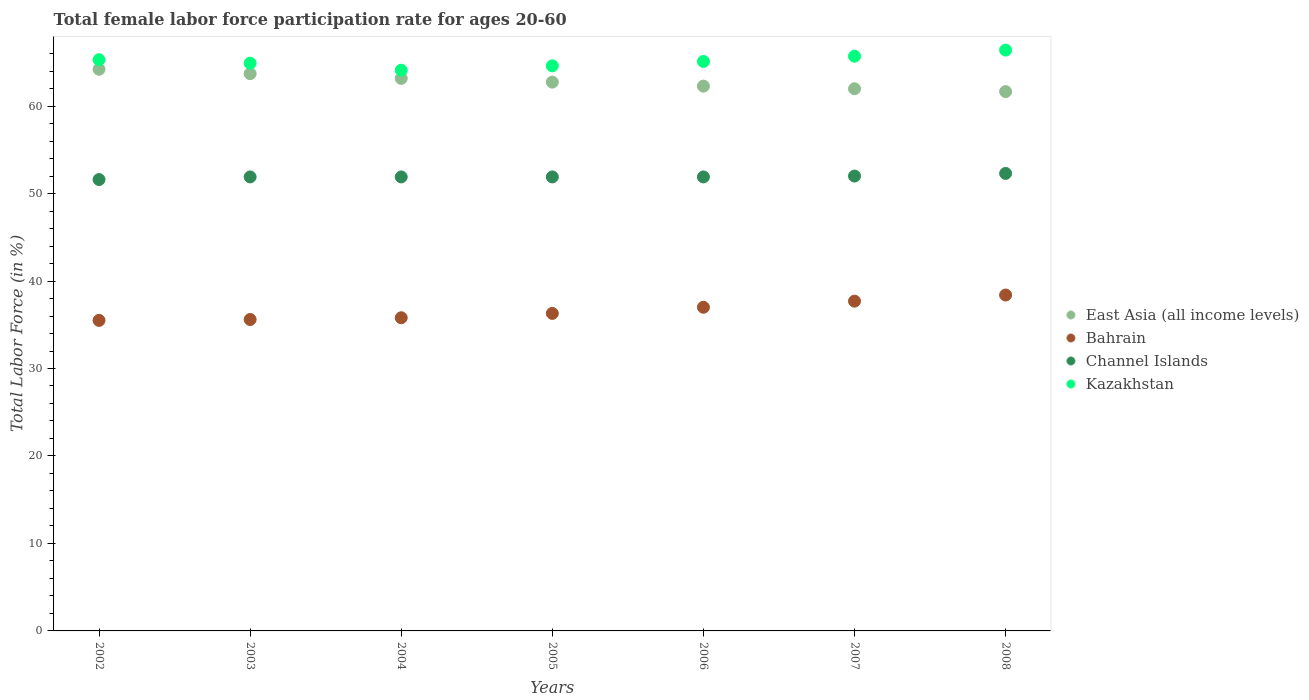How many different coloured dotlines are there?
Your response must be concise. 4. What is the female labor force participation rate in Kazakhstan in 2003?
Provide a succinct answer. 64.9. Across all years, what is the maximum female labor force participation rate in East Asia (all income levels)?
Provide a short and direct response. 64.21. Across all years, what is the minimum female labor force participation rate in Channel Islands?
Provide a short and direct response. 51.6. What is the total female labor force participation rate in Channel Islands in the graph?
Make the answer very short. 363.5. What is the difference between the female labor force participation rate in Channel Islands in 2002 and that in 2007?
Provide a short and direct response. -0.4. What is the difference between the female labor force participation rate in Bahrain in 2006 and the female labor force participation rate in Kazakhstan in 2008?
Ensure brevity in your answer.  -29.4. What is the average female labor force participation rate in Bahrain per year?
Offer a terse response. 36.61. In the year 2002, what is the difference between the female labor force participation rate in East Asia (all income levels) and female labor force participation rate in Channel Islands?
Provide a short and direct response. 12.61. In how many years, is the female labor force participation rate in East Asia (all income levels) greater than 16 %?
Make the answer very short. 7. Is the female labor force participation rate in Kazakhstan in 2002 less than that in 2007?
Your answer should be compact. Yes. Is the difference between the female labor force participation rate in East Asia (all income levels) in 2002 and 2006 greater than the difference between the female labor force participation rate in Channel Islands in 2002 and 2006?
Your answer should be compact. Yes. What is the difference between the highest and the second highest female labor force participation rate in Channel Islands?
Offer a terse response. 0.3. What is the difference between the highest and the lowest female labor force participation rate in Kazakhstan?
Offer a terse response. 2.3. Is it the case that in every year, the sum of the female labor force participation rate in East Asia (all income levels) and female labor force participation rate in Bahrain  is greater than the sum of female labor force participation rate in Kazakhstan and female labor force participation rate in Channel Islands?
Offer a terse response. No. Is the female labor force participation rate in East Asia (all income levels) strictly less than the female labor force participation rate in Kazakhstan over the years?
Keep it short and to the point. Yes. How many years are there in the graph?
Provide a succinct answer. 7. Are the values on the major ticks of Y-axis written in scientific E-notation?
Keep it short and to the point. No. Does the graph contain any zero values?
Provide a short and direct response. No. How many legend labels are there?
Offer a very short reply. 4. How are the legend labels stacked?
Offer a terse response. Vertical. What is the title of the graph?
Give a very brief answer. Total female labor force participation rate for ages 20-60. What is the label or title of the X-axis?
Give a very brief answer. Years. What is the label or title of the Y-axis?
Provide a succinct answer. Total Labor Force (in %). What is the Total Labor Force (in %) of East Asia (all income levels) in 2002?
Offer a very short reply. 64.21. What is the Total Labor Force (in %) of Bahrain in 2002?
Make the answer very short. 35.5. What is the Total Labor Force (in %) in Channel Islands in 2002?
Keep it short and to the point. 51.6. What is the Total Labor Force (in %) of Kazakhstan in 2002?
Give a very brief answer. 65.3. What is the Total Labor Force (in %) of East Asia (all income levels) in 2003?
Provide a succinct answer. 63.71. What is the Total Labor Force (in %) of Bahrain in 2003?
Give a very brief answer. 35.6. What is the Total Labor Force (in %) of Channel Islands in 2003?
Provide a succinct answer. 51.9. What is the Total Labor Force (in %) of Kazakhstan in 2003?
Make the answer very short. 64.9. What is the Total Labor Force (in %) in East Asia (all income levels) in 2004?
Your response must be concise. 63.16. What is the Total Labor Force (in %) of Bahrain in 2004?
Provide a succinct answer. 35.8. What is the Total Labor Force (in %) of Channel Islands in 2004?
Your answer should be compact. 51.9. What is the Total Labor Force (in %) of Kazakhstan in 2004?
Your response must be concise. 64.1. What is the Total Labor Force (in %) of East Asia (all income levels) in 2005?
Your answer should be compact. 62.74. What is the Total Labor Force (in %) of Bahrain in 2005?
Offer a terse response. 36.3. What is the Total Labor Force (in %) in Channel Islands in 2005?
Your response must be concise. 51.9. What is the Total Labor Force (in %) in Kazakhstan in 2005?
Ensure brevity in your answer.  64.6. What is the Total Labor Force (in %) in East Asia (all income levels) in 2006?
Your response must be concise. 62.28. What is the Total Labor Force (in %) of Channel Islands in 2006?
Offer a terse response. 51.9. What is the Total Labor Force (in %) of Kazakhstan in 2006?
Keep it short and to the point. 65.1. What is the Total Labor Force (in %) of East Asia (all income levels) in 2007?
Provide a succinct answer. 61.98. What is the Total Labor Force (in %) of Bahrain in 2007?
Offer a terse response. 37.7. What is the Total Labor Force (in %) of Channel Islands in 2007?
Ensure brevity in your answer.  52. What is the Total Labor Force (in %) in Kazakhstan in 2007?
Give a very brief answer. 65.7. What is the Total Labor Force (in %) of East Asia (all income levels) in 2008?
Keep it short and to the point. 61.66. What is the Total Labor Force (in %) of Bahrain in 2008?
Your response must be concise. 38.4. What is the Total Labor Force (in %) in Channel Islands in 2008?
Your answer should be very brief. 52.3. What is the Total Labor Force (in %) in Kazakhstan in 2008?
Provide a succinct answer. 66.4. Across all years, what is the maximum Total Labor Force (in %) of East Asia (all income levels)?
Give a very brief answer. 64.21. Across all years, what is the maximum Total Labor Force (in %) of Bahrain?
Provide a short and direct response. 38.4. Across all years, what is the maximum Total Labor Force (in %) of Channel Islands?
Your answer should be very brief. 52.3. Across all years, what is the maximum Total Labor Force (in %) of Kazakhstan?
Your response must be concise. 66.4. Across all years, what is the minimum Total Labor Force (in %) of East Asia (all income levels)?
Ensure brevity in your answer.  61.66. Across all years, what is the minimum Total Labor Force (in %) of Bahrain?
Keep it short and to the point. 35.5. Across all years, what is the minimum Total Labor Force (in %) of Channel Islands?
Your answer should be very brief. 51.6. Across all years, what is the minimum Total Labor Force (in %) of Kazakhstan?
Keep it short and to the point. 64.1. What is the total Total Labor Force (in %) of East Asia (all income levels) in the graph?
Give a very brief answer. 439.73. What is the total Total Labor Force (in %) of Bahrain in the graph?
Offer a very short reply. 256.3. What is the total Total Labor Force (in %) in Channel Islands in the graph?
Your answer should be compact. 363.5. What is the total Total Labor Force (in %) of Kazakhstan in the graph?
Your response must be concise. 456.1. What is the difference between the Total Labor Force (in %) in East Asia (all income levels) in 2002 and that in 2003?
Your response must be concise. 0.5. What is the difference between the Total Labor Force (in %) in Kazakhstan in 2002 and that in 2003?
Keep it short and to the point. 0.4. What is the difference between the Total Labor Force (in %) in East Asia (all income levels) in 2002 and that in 2004?
Your answer should be very brief. 1.04. What is the difference between the Total Labor Force (in %) in Kazakhstan in 2002 and that in 2004?
Offer a very short reply. 1.2. What is the difference between the Total Labor Force (in %) of East Asia (all income levels) in 2002 and that in 2005?
Provide a succinct answer. 1.47. What is the difference between the Total Labor Force (in %) in Bahrain in 2002 and that in 2005?
Your response must be concise. -0.8. What is the difference between the Total Labor Force (in %) of Kazakhstan in 2002 and that in 2005?
Provide a succinct answer. 0.7. What is the difference between the Total Labor Force (in %) in East Asia (all income levels) in 2002 and that in 2006?
Ensure brevity in your answer.  1.93. What is the difference between the Total Labor Force (in %) in Channel Islands in 2002 and that in 2006?
Keep it short and to the point. -0.3. What is the difference between the Total Labor Force (in %) of East Asia (all income levels) in 2002 and that in 2007?
Offer a very short reply. 2.23. What is the difference between the Total Labor Force (in %) in Bahrain in 2002 and that in 2007?
Give a very brief answer. -2.2. What is the difference between the Total Labor Force (in %) in Channel Islands in 2002 and that in 2007?
Keep it short and to the point. -0.4. What is the difference between the Total Labor Force (in %) in East Asia (all income levels) in 2002 and that in 2008?
Your answer should be compact. 2.55. What is the difference between the Total Labor Force (in %) of Bahrain in 2002 and that in 2008?
Offer a very short reply. -2.9. What is the difference between the Total Labor Force (in %) of Kazakhstan in 2002 and that in 2008?
Your answer should be very brief. -1.1. What is the difference between the Total Labor Force (in %) of East Asia (all income levels) in 2003 and that in 2004?
Make the answer very short. 0.54. What is the difference between the Total Labor Force (in %) in Channel Islands in 2003 and that in 2004?
Ensure brevity in your answer.  0. What is the difference between the Total Labor Force (in %) of Channel Islands in 2003 and that in 2005?
Keep it short and to the point. 0. What is the difference between the Total Labor Force (in %) in East Asia (all income levels) in 2003 and that in 2006?
Make the answer very short. 1.43. What is the difference between the Total Labor Force (in %) in Bahrain in 2003 and that in 2006?
Offer a very short reply. -1.4. What is the difference between the Total Labor Force (in %) in Kazakhstan in 2003 and that in 2006?
Your response must be concise. -0.2. What is the difference between the Total Labor Force (in %) of East Asia (all income levels) in 2003 and that in 2007?
Give a very brief answer. 1.73. What is the difference between the Total Labor Force (in %) of Kazakhstan in 2003 and that in 2007?
Your answer should be compact. -0.8. What is the difference between the Total Labor Force (in %) of East Asia (all income levels) in 2003 and that in 2008?
Provide a succinct answer. 2.05. What is the difference between the Total Labor Force (in %) of Bahrain in 2003 and that in 2008?
Your answer should be very brief. -2.8. What is the difference between the Total Labor Force (in %) of Channel Islands in 2003 and that in 2008?
Keep it short and to the point. -0.4. What is the difference between the Total Labor Force (in %) in East Asia (all income levels) in 2004 and that in 2005?
Make the answer very short. 0.42. What is the difference between the Total Labor Force (in %) of East Asia (all income levels) in 2004 and that in 2006?
Give a very brief answer. 0.88. What is the difference between the Total Labor Force (in %) of Kazakhstan in 2004 and that in 2006?
Offer a very short reply. -1. What is the difference between the Total Labor Force (in %) of East Asia (all income levels) in 2004 and that in 2007?
Your response must be concise. 1.18. What is the difference between the Total Labor Force (in %) of Channel Islands in 2004 and that in 2007?
Your answer should be very brief. -0.1. What is the difference between the Total Labor Force (in %) in Kazakhstan in 2004 and that in 2007?
Your answer should be compact. -1.6. What is the difference between the Total Labor Force (in %) of East Asia (all income levels) in 2004 and that in 2008?
Your response must be concise. 1.51. What is the difference between the Total Labor Force (in %) of East Asia (all income levels) in 2005 and that in 2006?
Your answer should be compact. 0.46. What is the difference between the Total Labor Force (in %) in Bahrain in 2005 and that in 2006?
Your answer should be compact. -0.7. What is the difference between the Total Labor Force (in %) in Channel Islands in 2005 and that in 2006?
Your answer should be very brief. 0. What is the difference between the Total Labor Force (in %) of Kazakhstan in 2005 and that in 2006?
Provide a short and direct response. -0.5. What is the difference between the Total Labor Force (in %) of East Asia (all income levels) in 2005 and that in 2007?
Your answer should be very brief. 0.76. What is the difference between the Total Labor Force (in %) in Channel Islands in 2005 and that in 2007?
Your response must be concise. -0.1. What is the difference between the Total Labor Force (in %) in East Asia (all income levels) in 2005 and that in 2008?
Give a very brief answer. 1.08. What is the difference between the Total Labor Force (in %) of Bahrain in 2005 and that in 2008?
Provide a short and direct response. -2.1. What is the difference between the Total Labor Force (in %) of Channel Islands in 2005 and that in 2008?
Give a very brief answer. -0.4. What is the difference between the Total Labor Force (in %) of Kazakhstan in 2005 and that in 2008?
Offer a very short reply. -1.8. What is the difference between the Total Labor Force (in %) in East Asia (all income levels) in 2006 and that in 2007?
Your answer should be compact. 0.3. What is the difference between the Total Labor Force (in %) in Channel Islands in 2006 and that in 2007?
Offer a terse response. -0.1. What is the difference between the Total Labor Force (in %) of East Asia (all income levels) in 2006 and that in 2008?
Your answer should be compact. 0.62. What is the difference between the Total Labor Force (in %) of Bahrain in 2006 and that in 2008?
Your answer should be compact. -1.4. What is the difference between the Total Labor Force (in %) of Kazakhstan in 2006 and that in 2008?
Keep it short and to the point. -1.3. What is the difference between the Total Labor Force (in %) in East Asia (all income levels) in 2007 and that in 2008?
Offer a very short reply. 0.33. What is the difference between the Total Labor Force (in %) in Channel Islands in 2007 and that in 2008?
Make the answer very short. -0.3. What is the difference between the Total Labor Force (in %) of East Asia (all income levels) in 2002 and the Total Labor Force (in %) of Bahrain in 2003?
Your response must be concise. 28.61. What is the difference between the Total Labor Force (in %) of East Asia (all income levels) in 2002 and the Total Labor Force (in %) of Channel Islands in 2003?
Ensure brevity in your answer.  12.31. What is the difference between the Total Labor Force (in %) in East Asia (all income levels) in 2002 and the Total Labor Force (in %) in Kazakhstan in 2003?
Offer a very short reply. -0.69. What is the difference between the Total Labor Force (in %) in Bahrain in 2002 and the Total Labor Force (in %) in Channel Islands in 2003?
Provide a succinct answer. -16.4. What is the difference between the Total Labor Force (in %) of Bahrain in 2002 and the Total Labor Force (in %) of Kazakhstan in 2003?
Give a very brief answer. -29.4. What is the difference between the Total Labor Force (in %) in Channel Islands in 2002 and the Total Labor Force (in %) in Kazakhstan in 2003?
Keep it short and to the point. -13.3. What is the difference between the Total Labor Force (in %) of East Asia (all income levels) in 2002 and the Total Labor Force (in %) of Bahrain in 2004?
Offer a terse response. 28.41. What is the difference between the Total Labor Force (in %) of East Asia (all income levels) in 2002 and the Total Labor Force (in %) of Channel Islands in 2004?
Make the answer very short. 12.31. What is the difference between the Total Labor Force (in %) of East Asia (all income levels) in 2002 and the Total Labor Force (in %) of Kazakhstan in 2004?
Keep it short and to the point. 0.11. What is the difference between the Total Labor Force (in %) in Bahrain in 2002 and the Total Labor Force (in %) in Channel Islands in 2004?
Provide a short and direct response. -16.4. What is the difference between the Total Labor Force (in %) in Bahrain in 2002 and the Total Labor Force (in %) in Kazakhstan in 2004?
Offer a very short reply. -28.6. What is the difference between the Total Labor Force (in %) in Channel Islands in 2002 and the Total Labor Force (in %) in Kazakhstan in 2004?
Keep it short and to the point. -12.5. What is the difference between the Total Labor Force (in %) in East Asia (all income levels) in 2002 and the Total Labor Force (in %) in Bahrain in 2005?
Ensure brevity in your answer.  27.91. What is the difference between the Total Labor Force (in %) of East Asia (all income levels) in 2002 and the Total Labor Force (in %) of Channel Islands in 2005?
Give a very brief answer. 12.31. What is the difference between the Total Labor Force (in %) of East Asia (all income levels) in 2002 and the Total Labor Force (in %) of Kazakhstan in 2005?
Make the answer very short. -0.39. What is the difference between the Total Labor Force (in %) of Bahrain in 2002 and the Total Labor Force (in %) of Channel Islands in 2005?
Keep it short and to the point. -16.4. What is the difference between the Total Labor Force (in %) of Bahrain in 2002 and the Total Labor Force (in %) of Kazakhstan in 2005?
Keep it short and to the point. -29.1. What is the difference between the Total Labor Force (in %) in East Asia (all income levels) in 2002 and the Total Labor Force (in %) in Bahrain in 2006?
Provide a short and direct response. 27.21. What is the difference between the Total Labor Force (in %) in East Asia (all income levels) in 2002 and the Total Labor Force (in %) in Channel Islands in 2006?
Ensure brevity in your answer.  12.31. What is the difference between the Total Labor Force (in %) of East Asia (all income levels) in 2002 and the Total Labor Force (in %) of Kazakhstan in 2006?
Your answer should be very brief. -0.89. What is the difference between the Total Labor Force (in %) of Bahrain in 2002 and the Total Labor Force (in %) of Channel Islands in 2006?
Make the answer very short. -16.4. What is the difference between the Total Labor Force (in %) in Bahrain in 2002 and the Total Labor Force (in %) in Kazakhstan in 2006?
Your response must be concise. -29.6. What is the difference between the Total Labor Force (in %) in Channel Islands in 2002 and the Total Labor Force (in %) in Kazakhstan in 2006?
Offer a very short reply. -13.5. What is the difference between the Total Labor Force (in %) of East Asia (all income levels) in 2002 and the Total Labor Force (in %) of Bahrain in 2007?
Offer a very short reply. 26.51. What is the difference between the Total Labor Force (in %) of East Asia (all income levels) in 2002 and the Total Labor Force (in %) of Channel Islands in 2007?
Offer a very short reply. 12.21. What is the difference between the Total Labor Force (in %) in East Asia (all income levels) in 2002 and the Total Labor Force (in %) in Kazakhstan in 2007?
Your response must be concise. -1.49. What is the difference between the Total Labor Force (in %) of Bahrain in 2002 and the Total Labor Force (in %) of Channel Islands in 2007?
Your answer should be very brief. -16.5. What is the difference between the Total Labor Force (in %) of Bahrain in 2002 and the Total Labor Force (in %) of Kazakhstan in 2007?
Provide a succinct answer. -30.2. What is the difference between the Total Labor Force (in %) in Channel Islands in 2002 and the Total Labor Force (in %) in Kazakhstan in 2007?
Make the answer very short. -14.1. What is the difference between the Total Labor Force (in %) in East Asia (all income levels) in 2002 and the Total Labor Force (in %) in Bahrain in 2008?
Give a very brief answer. 25.81. What is the difference between the Total Labor Force (in %) of East Asia (all income levels) in 2002 and the Total Labor Force (in %) of Channel Islands in 2008?
Your answer should be very brief. 11.91. What is the difference between the Total Labor Force (in %) in East Asia (all income levels) in 2002 and the Total Labor Force (in %) in Kazakhstan in 2008?
Provide a short and direct response. -2.19. What is the difference between the Total Labor Force (in %) in Bahrain in 2002 and the Total Labor Force (in %) in Channel Islands in 2008?
Offer a terse response. -16.8. What is the difference between the Total Labor Force (in %) of Bahrain in 2002 and the Total Labor Force (in %) of Kazakhstan in 2008?
Ensure brevity in your answer.  -30.9. What is the difference between the Total Labor Force (in %) in Channel Islands in 2002 and the Total Labor Force (in %) in Kazakhstan in 2008?
Give a very brief answer. -14.8. What is the difference between the Total Labor Force (in %) in East Asia (all income levels) in 2003 and the Total Labor Force (in %) in Bahrain in 2004?
Your answer should be very brief. 27.91. What is the difference between the Total Labor Force (in %) of East Asia (all income levels) in 2003 and the Total Labor Force (in %) of Channel Islands in 2004?
Offer a very short reply. 11.81. What is the difference between the Total Labor Force (in %) of East Asia (all income levels) in 2003 and the Total Labor Force (in %) of Kazakhstan in 2004?
Give a very brief answer. -0.39. What is the difference between the Total Labor Force (in %) in Bahrain in 2003 and the Total Labor Force (in %) in Channel Islands in 2004?
Offer a terse response. -16.3. What is the difference between the Total Labor Force (in %) of Bahrain in 2003 and the Total Labor Force (in %) of Kazakhstan in 2004?
Your answer should be very brief. -28.5. What is the difference between the Total Labor Force (in %) in Channel Islands in 2003 and the Total Labor Force (in %) in Kazakhstan in 2004?
Your answer should be compact. -12.2. What is the difference between the Total Labor Force (in %) in East Asia (all income levels) in 2003 and the Total Labor Force (in %) in Bahrain in 2005?
Your answer should be very brief. 27.41. What is the difference between the Total Labor Force (in %) in East Asia (all income levels) in 2003 and the Total Labor Force (in %) in Channel Islands in 2005?
Make the answer very short. 11.81. What is the difference between the Total Labor Force (in %) of East Asia (all income levels) in 2003 and the Total Labor Force (in %) of Kazakhstan in 2005?
Ensure brevity in your answer.  -0.89. What is the difference between the Total Labor Force (in %) of Bahrain in 2003 and the Total Labor Force (in %) of Channel Islands in 2005?
Offer a very short reply. -16.3. What is the difference between the Total Labor Force (in %) of East Asia (all income levels) in 2003 and the Total Labor Force (in %) of Bahrain in 2006?
Provide a succinct answer. 26.71. What is the difference between the Total Labor Force (in %) of East Asia (all income levels) in 2003 and the Total Labor Force (in %) of Channel Islands in 2006?
Keep it short and to the point. 11.81. What is the difference between the Total Labor Force (in %) of East Asia (all income levels) in 2003 and the Total Labor Force (in %) of Kazakhstan in 2006?
Keep it short and to the point. -1.39. What is the difference between the Total Labor Force (in %) in Bahrain in 2003 and the Total Labor Force (in %) in Channel Islands in 2006?
Make the answer very short. -16.3. What is the difference between the Total Labor Force (in %) of Bahrain in 2003 and the Total Labor Force (in %) of Kazakhstan in 2006?
Your answer should be compact. -29.5. What is the difference between the Total Labor Force (in %) in Channel Islands in 2003 and the Total Labor Force (in %) in Kazakhstan in 2006?
Make the answer very short. -13.2. What is the difference between the Total Labor Force (in %) of East Asia (all income levels) in 2003 and the Total Labor Force (in %) of Bahrain in 2007?
Your response must be concise. 26.01. What is the difference between the Total Labor Force (in %) of East Asia (all income levels) in 2003 and the Total Labor Force (in %) of Channel Islands in 2007?
Offer a terse response. 11.71. What is the difference between the Total Labor Force (in %) of East Asia (all income levels) in 2003 and the Total Labor Force (in %) of Kazakhstan in 2007?
Your answer should be compact. -1.99. What is the difference between the Total Labor Force (in %) of Bahrain in 2003 and the Total Labor Force (in %) of Channel Islands in 2007?
Make the answer very short. -16.4. What is the difference between the Total Labor Force (in %) in Bahrain in 2003 and the Total Labor Force (in %) in Kazakhstan in 2007?
Provide a short and direct response. -30.1. What is the difference between the Total Labor Force (in %) of Channel Islands in 2003 and the Total Labor Force (in %) of Kazakhstan in 2007?
Offer a very short reply. -13.8. What is the difference between the Total Labor Force (in %) of East Asia (all income levels) in 2003 and the Total Labor Force (in %) of Bahrain in 2008?
Provide a succinct answer. 25.31. What is the difference between the Total Labor Force (in %) of East Asia (all income levels) in 2003 and the Total Labor Force (in %) of Channel Islands in 2008?
Offer a terse response. 11.41. What is the difference between the Total Labor Force (in %) in East Asia (all income levels) in 2003 and the Total Labor Force (in %) in Kazakhstan in 2008?
Offer a very short reply. -2.69. What is the difference between the Total Labor Force (in %) of Bahrain in 2003 and the Total Labor Force (in %) of Channel Islands in 2008?
Provide a short and direct response. -16.7. What is the difference between the Total Labor Force (in %) in Bahrain in 2003 and the Total Labor Force (in %) in Kazakhstan in 2008?
Provide a short and direct response. -30.8. What is the difference between the Total Labor Force (in %) of Channel Islands in 2003 and the Total Labor Force (in %) of Kazakhstan in 2008?
Offer a very short reply. -14.5. What is the difference between the Total Labor Force (in %) of East Asia (all income levels) in 2004 and the Total Labor Force (in %) of Bahrain in 2005?
Offer a very short reply. 26.86. What is the difference between the Total Labor Force (in %) of East Asia (all income levels) in 2004 and the Total Labor Force (in %) of Channel Islands in 2005?
Make the answer very short. 11.26. What is the difference between the Total Labor Force (in %) of East Asia (all income levels) in 2004 and the Total Labor Force (in %) of Kazakhstan in 2005?
Provide a short and direct response. -1.44. What is the difference between the Total Labor Force (in %) in Bahrain in 2004 and the Total Labor Force (in %) in Channel Islands in 2005?
Your answer should be compact. -16.1. What is the difference between the Total Labor Force (in %) of Bahrain in 2004 and the Total Labor Force (in %) of Kazakhstan in 2005?
Offer a very short reply. -28.8. What is the difference between the Total Labor Force (in %) of Channel Islands in 2004 and the Total Labor Force (in %) of Kazakhstan in 2005?
Ensure brevity in your answer.  -12.7. What is the difference between the Total Labor Force (in %) of East Asia (all income levels) in 2004 and the Total Labor Force (in %) of Bahrain in 2006?
Make the answer very short. 26.16. What is the difference between the Total Labor Force (in %) of East Asia (all income levels) in 2004 and the Total Labor Force (in %) of Channel Islands in 2006?
Ensure brevity in your answer.  11.26. What is the difference between the Total Labor Force (in %) in East Asia (all income levels) in 2004 and the Total Labor Force (in %) in Kazakhstan in 2006?
Your answer should be compact. -1.94. What is the difference between the Total Labor Force (in %) of Bahrain in 2004 and the Total Labor Force (in %) of Channel Islands in 2006?
Ensure brevity in your answer.  -16.1. What is the difference between the Total Labor Force (in %) of Bahrain in 2004 and the Total Labor Force (in %) of Kazakhstan in 2006?
Provide a short and direct response. -29.3. What is the difference between the Total Labor Force (in %) of East Asia (all income levels) in 2004 and the Total Labor Force (in %) of Bahrain in 2007?
Make the answer very short. 25.46. What is the difference between the Total Labor Force (in %) of East Asia (all income levels) in 2004 and the Total Labor Force (in %) of Channel Islands in 2007?
Your answer should be very brief. 11.16. What is the difference between the Total Labor Force (in %) of East Asia (all income levels) in 2004 and the Total Labor Force (in %) of Kazakhstan in 2007?
Offer a terse response. -2.54. What is the difference between the Total Labor Force (in %) of Bahrain in 2004 and the Total Labor Force (in %) of Channel Islands in 2007?
Your answer should be compact. -16.2. What is the difference between the Total Labor Force (in %) in Bahrain in 2004 and the Total Labor Force (in %) in Kazakhstan in 2007?
Offer a very short reply. -29.9. What is the difference between the Total Labor Force (in %) of Channel Islands in 2004 and the Total Labor Force (in %) of Kazakhstan in 2007?
Offer a very short reply. -13.8. What is the difference between the Total Labor Force (in %) in East Asia (all income levels) in 2004 and the Total Labor Force (in %) in Bahrain in 2008?
Provide a short and direct response. 24.76. What is the difference between the Total Labor Force (in %) of East Asia (all income levels) in 2004 and the Total Labor Force (in %) of Channel Islands in 2008?
Your response must be concise. 10.86. What is the difference between the Total Labor Force (in %) of East Asia (all income levels) in 2004 and the Total Labor Force (in %) of Kazakhstan in 2008?
Make the answer very short. -3.24. What is the difference between the Total Labor Force (in %) in Bahrain in 2004 and the Total Labor Force (in %) in Channel Islands in 2008?
Give a very brief answer. -16.5. What is the difference between the Total Labor Force (in %) in Bahrain in 2004 and the Total Labor Force (in %) in Kazakhstan in 2008?
Provide a short and direct response. -30.6. What is the difference between the Total Labor Force (in %) of East Asia (all income levels) in 2005 and the Total Labor Force (in %) of Bahrain in 2006?
Provide a short and direct response. 25.74. What is the difference between the Total Labor Force (in %) in East Asia (all income levels) in 2005 and the Total Labor Force (in %) in Channel Islands in 2006?
Keep it short and to the point. 10.84. What is the difference between the Total Labor Force (in %) in East Asia (all income levels) in 2005 and the Total Labor Force (in %) in Kazakhstan in 2006?
Offer a very short reply. -2.36. What is the difference between the Total Labor Force (in %) in Bahrain in 2005 and the Total Labor Force (in %) in Channel Islands in 2006?
Keep it short and to the point. -15.6. What is the difference between the Total Labor Force (in %) in Bahrain in 2005 and the Total Labor Force (in %) in Kazakhstan in 2006?
Offer a terse response. -28.8. What is the difference between the Total Labor Force (in %) of East Asia (all income levels) in 2005 and the Total Labor Force (in %) of Bahrain in 2007?
Provide a short and direct response. 25.04. What is the difference between the Total Labor Force (in %) of East Asia (all income levels) in 2005 and the Total Labor Force (in %) of Channel Islands in 2007?
Offer a terse response. 10.74. What is the difference between the Total Labor Force (in %) of East Asia (all income levels) in 2005 and the Total Labor Force (in %) of Kazakhstan in 2007?
Offer a very short reply. -2.96. What is the difference between the Total Labor Force (in %) of Bahrain in 2005 and the Total Labor Force (in %) of Channel Islands in 2007?
Provide a succinct answer. -15.7. What is the difference between the Total Labor Force (in %) of Bahrain in 2005 and the Total Labor Force (in %) of Kazakhstan in 2007?
Make the answer very short. -29.4. What is the difference between the Total Labor Force (in %) of East Asia (all income levels) in 2005 and the Total Labor Force (in %) of Bahrain in 2008?
Offer a very short reply. 24.34. What is the difference between the Total Labor Force (in %) of East Asia (all income levels) in 2005 and the Total Labor Force (in %) of Channel Islands in 2008?
Your answer should be very brief. 10.44. What is the difference between the Total Labor Force (in %) in East Asia (all income levels) in 2005 and the Total Labor Force (in %) in Kazakhstan in 2008?
Ensure brevity in your answer.  -3.66. What is the difference between the Total Labor Force (in %) of Bahrain in 2005 and the Total Labor Force (in %) of Channel Islands in 2008?
Offer a terse response. -16. What is the difference between the Total Labor Force (in %) in Bahrain in 2005 and the Total Labor Force (in %) in Kazakhstan in 2008?
Offer a terse response. -30.1. What is the difference between the Total Labor Force (in %) of East Asia (all income levels) in 2006 and the Total Labor Force (in %) of Bahrain in 2007?
Give a very brief answer. 24.58. What is the difference between the Total Labor Force (in %) in East Asia (all income levels) in 2006 and the Total Labor Force (in %) in Channel Islands in 2007?
Provide a succinct answer. 10.28. What is the difference between the Total Labor Force (in %) of East Asia (all income levels) in 2006 and the Total Labor Force (in %) of Kazakhstan in 2007?
Offer a very short reply. -3.42. What is the difference between the Total Labor Force (in %) of Bahrain in 2006 and the Total Labor Force (in %) of Kazakhstan in 2007?
Give a very brief answer. -28.7. What is the difference between the Total Labor Force (in %) of East Asia (all income levels) in 2006 and the Total Labor Force (in %) of Bahrain in 2008?
Ensure brevity in your answer.  23.88. What is the difference between the Total Labor Force (in %) of East Asia (all income levels) in 2006 and the Total Labor Force (in %) of Channel Islands in 2008?
Give a very brief answer. 9.98. What is the difference between the Total Labor Force (in %) in East Asia (all income levels) in 2006 and the Total Labor Force (in %) in Kazakhstan in 2008?
Your answer should be compact. -4.12. What is the difference between the Total Labor Force (in %) of Bahrain in 2006 and the Total Labor Force (in %) of Channel Islands in 2008?
Offer a terse response. -15.3. What is the difference between the Total Labor Force (in %) of Bahrain in 2006 and the Total Labor Force (in %) of Kazakhstan in 2008?
Give a very brief answer. -29.4. What is the difference between the Total Labor Force (in %) of East Asia (all income levels) in 2007 and the Total Labor Force (in %) of Bahrain in 2008?
Give a very brief answer. 23.58. What is the difference between the Total Labor Force (in %) in East Asia (all income levels) in 2007 and the Total Labor Force (in %) in Channel Islands in 2008?
Make the answer very short. 9.68. What is the difference between the Total Labor Force (in %) of East Asia (all income levels) in 2007 and the Total Labor Force (in %) of Kazakhstan in 2008?
Your answer should be compact. -4.42. What is the difference between the Total Labor Force (in %) of Bahrain in 2007 and the Total Labor Force (in %) of Channel Islands in 2008?
Ensure brevity in your answer.  -14.6. What is the difference between the Total Labor Force (in %) in Bahrain in 2007 and the Total Labor Force (in %) in Kazakhstan in 2008?
Your answer should be compact. -28.7. What is the difference between the Total Labor Force (in %) of Channel Islands in 2007 and the Total Labor Force (in %) of Kazakhstan in 2008?
Make the answer very short. -14.4. What is the average Total Labor Force (in %) of East Asia (all income levels) per year?
Make the answer very short. 62.82. What is the average Total Labor Force (in %) in Bahrain per year?
Offer a terse response. 36.61. What is the average Total Labor Force (in %) of Channel Islands per year?
Offer a very short reply. 51.93. What is the average Total Labor Force (in %) in Kazakhstan per year?
Ensure brevity in your answer.  65.16. In the year 2002, what is the difference between the Total Labor Force (in %) of East Asia (all income levels) and Total Labor Force (in %) of Bahrain?
Offer a very short reply. 28.71. In the year 2002, what is the difference between the Total Labor Force (in %) of East Asia (all income levels) and Total Labor Force (in %) of Channel Islands?
Your response must be concise. 12.61. In the year 2002, what is the difference between the Total Labor Force (in %) in East Asia (all income levels) and Total Labor Force (in %) in Kazakhstan?
Offer a very short reply. -1.09. In the year 2002, what is the difference between the Total Labor Force (in %) in Bahrain and Total Labor Force (in %) in Channel Islands?
Keep it short and to the point. -16.1. In the year 2002, what is the difference between the Total Labor Force (in %) of Bahrain and Total Labor Force (in %) of Kazakhstan?
Your answer should be compact. -29.8. In the year 2002, what is the difference between the Total Labor Force (in %) of Channel Islands and Total Labor Force (in %) of Kazakhstan?
Your response must be concise. -13.7. In the year 2003, what is the difference between the Total Labor Force (in %) in East Asia (all income levels) and Total Labor Force (in %) in Bahrain?
Your answer should be compact. 28.11. In the year 2003, what is the difference between the Total Labor Force (in %) of East Asia (all income levels) and Total Labor Force (in %) of Channel Islands?
Offer a terse response. 11.81. In the year 2003, what is the difference between the Total Labor Force (in %) in East Asia (all income levels) and Total Labor Force (in %) in Kazakhstan?
Provide a succinct answer. -1.19. In the year 2003, what is the difference between the Total Labor Force (in %) in Bahrain and Total Labor Force (in %) in Channel Islands?
Make the answer very short. -16.3. In the year 2003, what is the difference between the Total Labor Force (in %) in Bahrain and Total Labor Force (in %) in Kazakhstan?
Ensure brevity in your answer.  -29.3. In the year 2004, what is the difference between the Total Labor Force (in %) in East Asia (all income levels) and Total Labor Force (in %) in Bahrain?
Your answer should be compact. 27.36. In the year 2004, what is the difference between the Total Labor Force (in %) of East Asia (all income levels) and Total Labor Force (in %) of Channel Islands?
Provide a succinct answer. 11.26. In the year 2004, what is the difference between the Total Labor Force (in %) of East Asia (all income levels) and Total Labor Force (in %) of Kazakhstan?
Offer a very short reply. -0.94. In the year 2004, what is the difference between the Total Labor Force (in %) of Bahrain and Total Labor Force (in %) of Channel Islands?
Your response must be concise. -16.1. In the year 2004, what is the difference between the Total Labor Force (in %) in Bahrain and Total Labor Force (in %) in Kazakhstan?
Give a very brief answer. -28.3. In the year 2005, what is the difference between the Total Labor Force (in %) of East Asia (all income levels) and Total Labor Force (in %) of Bahrain?
Provide a succinct answer. 26.44. In the year 2005, what is the difference between the Total Labor Force (in %) of East Asia (all income levels) and Total Labor Force (in %) of Channel Islands?
Offer a terse response. 10.84. In the year 2005, what is the difference between the Total Labor Force (in %) of East Asia (all income levels) and Total Labor Force (in %) of Kazakhstan?
Your answer should be compact. -1.86. In the year 2005, what is the difference between the Total Labor Force (in %) of Bahrain and Total Labor Force (in %) of Channel Islands?
Provide a short and direct response. -15.6. In the year 2005, what is the difference between the Total Labor Force (in %) in Bahrain and Total Labor Force (in %) in Kazakhstan?
Provide a succinct answer. -28.3. In the year 2006, what is the difference between the Total Labor Force (in %) in East Asia (all income levels) and Total Labor Force (in %) in Bahrain?
Ensure brevity in your answer.  25.28. In the year 2006, what is the difference between the Total Labor Force (in %) in East Asia (all income levels) and Total Labor Force (in %) in Channel Islands?
Give a very brief answer. 10.38. In the year 2006, what is the difference between the Total Labor Force (in %) of East Asia (all income levels) and Total Labor Force (in %) of Kazakhstan?
Provide a short and direct response. -2.82. In the year 2006, what is the difference between the Total Labor Force (in %) of Bahrain and Total Labor Force (in %) of Channel Islands?
Offer a terse response. -14.9. In the year 2006, what is the difference between the Total Labor Force (in %) in Bahrain and Total Labor Force (in %) in Kazakhstan?
Your answer should be very brief. -28.1. In the year 2007, what is the difference between the Total Labor Force (in %) in East Asia (all income levels) and Total Labor Force (in %) in Bahrain?
Keep it short and to the point. 24.28. In the year 2007, what is the difference between the Total Labor Force (in %) of East Asia (all income levels) and Total Labor Force (in %) of Channel Islands?
Give a very brief answer. 9.98. In the year 2007, what is the difference between the Total Labor Force (in %) in East Asia (all income levels) and Total Labor Force (in %) in Kazakhstan?
Your answer should be compact. -3.72. In the year 2007, what is the difference between the Total Labor Force (in %) of Bahrain and Total Labor Force (in %) of Channel Islands?
Ensure brevity in your answer.  -14.3. In the year 2007, what is the difference between the Total Labor Force (in %) of Bahrain and Total Labor Force (in %) of Kazakhstan?
Your response must be concise. -28. In the year 2007, what is the difference between the Total Labor Force (in %) of Channel Islands and Total Labor Force (in %) of Kazakhstan?
Ensure brevity in your answer.  -13.7. In the year 2008, what is the difference between the Total Labor Force (in %) of East Asia (all income levels) and Total Labor Force (in %) of Bahrain?
Give a very brief answer. 23.26. In the year 2008, what is the difference between the Total Labor Force (in %) in East Asia (all income levels) and Total Labor Force (in %) in Channel Islands?
Provide a short and direct response. 9.36. In the year 2008, what is the difference between the Total Labor Force (in %) of East Asia (all income levels) and Total Labor Force (in %) of Kazakhstan?
Your answer should be compact. -4.74. In the year 2008, what is the difference between the Total Labor Force (in %) of Channel Islands and Total Labor Force (in %) of Kazakhstan?
Your answer should be compact. -14.1. What is the ratio of the Total Labor Force (in %) in East Asia (all income levels) in 2002 to that in 2003?
Provide a short and direct response. 1.01. What is the ratio of the Total Labor Force (in %) in Kazakhstan in 2002 to that in 2003?
Offer a terse response. 1.01. What is the ratio of the Total Labor Force (in %) in East Asia (all income levels) in 2002 to that in 2004?
Provide a short and direct response. 1.02. What is the ratio of the Total Labor Force (in %) in Kazakhstan in 2002 to that in 2004?
Keep it short and to the point. 1.02. What is the ratio of the Total Labor Force (in %) in East Asia (all income levels) in 2002 to that in 2005?
Your response must be concise. 1.02. What is the ratio of the Total Labor Force (in %) in Bahrain in 2002 to that in 2005?
Your answer should be compact. 0.98. What is the ratio of the Total Labor Force (in %) of Kazakhstan in 2002 to that in 2005?
Your answer should be compact. 1.01. What is the ratio of the Total Labor Force (in %) in East Asia (all income levels) in 2002 to that in 2006?
Your answer should be very brief. 1.03. What is the ratio of the Total Labor Force (in %) in Bahrain in 2002 to that in 2006?
Keep it short and to the point. 0.96. What is the ratio of the Total Labor Force (in %) of Channel Islands in 2002 to that in 2006?
Offer a terse response. 0.99. What is the ratio of the Total Labor Force (in %) of Kazakhstan in 2002 to that in 2006?
Make the answer very short. 1. What is the ratio of the Total Labor Force (in %) in East Asia (all income levels) in 2002 to that in 2007?
Make the answer very short. 1.04. What is the ratio of the Total Labor Force (in %) in Bahrain in 2002 to that in 2007?
Make the answer very short. 0.94. What is the ratio of the Total Labor Force (in %) in Channel Islands in 2002 to that in 2007?
Your answer should be very brief. 0.99. What is the ratio of the Total Labor Force (in %) in Kazakhstan in 2002 to that in 2007?
Your answer should be very brief. 0.99. What is the ratio of the Total Labor Force (in %) of East Asia (all income levels) in 2002 to that in 2008?
Provide a succinct answer. 1.04. What is the ratio of the Total Labor Force (in %) in Bahrain in 2002 to that in 2008?
Your answer should be very brief. 0.92. What is the ratio of the Total Labor Force (in %) in Channel Islands in 2002 to that in 2008?
Offer a terse response. 0.99. What is the ratio of the Total Labor Force (in %) of Kazakhstan in 2002 to that in 2008?
Give a very brief answer. 0.98. What is the ratio of the Total Labor Force (in %) of East Asia (all income levels) in 2003 to that in 2004?
Ensure brevity in your answer.  1.01. What is the ratio of the Total Labor Force (in %) in Bahrain in 2003 to that in 2004?
Offer a terse response. 0.99. What is the ratio of the Total Labor Force (in %) in Kazakhstan in 2003 to that in 2004?
Your response must be concise. 1.01. What is the ratio of the Total Labor Force (in %) of East Asia (all income levels) in 2003 to that in 2005?
Keep it short and to the point. 1.02. What is the ratio of the Total Labor Force (in %) in Bahrain in 2003 to that in 2005?
Make the answer very short. 0.98. What is the ratio of the Total Labor Force (in %) of Kazakhstan in 2003 to that in 2005?
Keep it short and to the point. 1. What is the ratio of the Total Labor Force (in %) of East Asia (all income levels) in 2003 to that in 2006?
Keep it short and to the point. 1.02. What is the ratio of the Total Labor Force (in %) in Bahrain in 2003 to that in 2006?
Your answer should be compact. 0.96. What is the ratio of the Total Labor Force (in %) of Kazakhstan in 2003 to that in 2006?
Keep it short and to the point. 1. What is the ratio of the Total Labor Force (in %) in East Asia (all income levels) in 2003 to that in 2007?
Give a very brief answer. 1.03. What is the ratio of the Total Labor Force (in %) of Bahrain in 2003 to that in 2007?
Make the answer very short. 0.94. What is the ratio of the Total Labor Force (in %) in Channel Islands in 2003 to that in 2007?
Give a very brief answer. 1. What is the ratio of the Total Labor Force (in %) of East Asia (all income levels) in 2003 to that in 2008?
Your answer should be compact. 1.03. What is the ratio of the Total Labor Force (in %) of Bahrain in 2003 to that in 2008?
Your answer should be very brief. 0.93. What is the ratio of the Total Labor Force (in %) in Kazakhstan in 2003 to that in 2008?
Keep it short and to the point. 0.98. What is the ratio of the Total Labor Force (in %) in East Asia (all income levels) in 2004 to that in 2005?
Make the answer very short. 1.01. What is the ratio of the Total Labor Force (in %) of Bahrain in 2004 to that in 2005?
Ensure brevity in your answer.  0.99. What is the ratio of the Total Labor Force (in %) of Kazakhstan in 2004 to that in 2005?
Give a very brief answer. 0.99. What is the ratio of the Total Labor Force (in %) in East Asia (all income levels) in 2004 to that in 2006?
Your response must be concise. 1.01. What is the ratio of the Total Labor Force (in %) in Bahrain in 2004 to that in 2006?
Provide a succinct answer. 0.97. What is the ratio of the Total Labor Force (in %) in Channel Islands in 2004 to that in 2006?
Give a very brief answer. 1. What is the ratio of the Total Labor Force (in %) of Kazakhstan in 2004 to that in 2006?
Offer a very short reply. 0.98. What is the ratio of the Total Labor Force (in %) in East Asia (all income levels) in 2004 to that in 2007?
Your response must be concise. 1.02. What is the ratio of the Total Labor Force (in %) in Bahrain in 2004 to that in 2007?
Your answer should be compact. 0.95. What is the ratio of the Total Labor Force (in %) in Channel Islands in 2004 to that in 2007?
Your answer should be very brief. 1. What is the ratio of the Total Labor Force (in %) of Kazakhstan in 2004 to that in 2007?
Your answer should be compact. 0.98. What is the ratio of the Total Labor Force (in %) in East Asia (all income levels) in 2004 to that in 2008?
Provide a succinct answer. 1.02. What is the ratio of the Total Labor Force (in %) of Bahrain in 2004 to that in 2008?
Your response must be concise. 0.93. What is the ratio of the Total Labor Force (in %) in Channel Islands in 2004 to that in 2008?
Give a very brief answer. 0.99. What is the ratio of the Total Labor Force (in %) in Kazakhstan in 2004 to that in 2008?
Offer a very short reply. 0.97. What is the ratio of the Total Labor Force (in %) in East Asia (all income levels) in 2005 to that in 2006?
Your answer should be compact. 1.01. What is the ratio of the Total Labor Force (in %) of Bahrain in 2005 to that in 2006?
Give a very brief answer. 0.98. What is the ratio of the Total Labor Force (in %) in Channel Islands in 2005 to that in 2006?
Offer a very short reply. 1. What is the ratio of the Total Labor Force (in %) in East Asia (all income levels) in 2005 to that in 2007?
Offer a terse response. 1.01. What is the ratio of the Total Labor Force (in %) of Bahrain in 2005 to that in 2007?
Make the answer very short. 0.96. What is the ratio of the Total Labor Force (in %) of Channel Islands in 2005 to that in 2007?
Your answer should be very brief. 1. What is the ratio of the Total Labor Force (in %) in Kazakhstan in 2005 to that in 2007?
Your response must be concise. 0.98. What is the ratio of the Total Labor Force (in %) in East Asia (all income levels) in 2005 to that in 2008?
Your response must be concise. 1.02. What is the ratio of the Total Labor Force (in %) in Bahrain in 2005 to that in 2008?
Give a very brief answer. 0.95. What is the ratio of the Total Labor Force (in %) in Kazakhstan in 2005 to that in 2008?
Provide a short and direct response. 0.97. What is the ratio of the Total Labor Force (in %) in East Asia (all income levels) in 2006 to that in 2007?
Your answer should be very brief. 1. What is the ratio of the Total Labor Force (in %) in Bahrain in 2006 to that in 2007?
Keep it short and to the point. 0.98. What is the ratio of the Total Labor Force (in %) of Kazakhstan in 2006 to that in 2007?
Your answer should be very brief. 0.99. What is the ratio of the Total Labor Force (in %) of Bahrain in 2006 to that in 2008?
Make the answer very short. 0.96. What is the ratio of the Total Labor Force (in %) of Kazakhstan in 2006 to that in 2008?
Offer a terse response. 0.98. What is the ratio of the Total Labor Force (in %) in Bahrain in 2007 to that in 2008?
Give a very brief answer. 0.98. What is the difference between the highest and the second highest Total Labor Force (in %) in East Asia (all income levels)?
Your answer should be compact. 0.5. What is the difference between the highest and the second highest Total Labor Force (in %) of Kazakhstan?
Offer a terse response. 0.7. What is the difference between the highest and the lowest Total Labor Force (in %) of East Asia (all income levels)?
Offer a terse response. 2.55. 